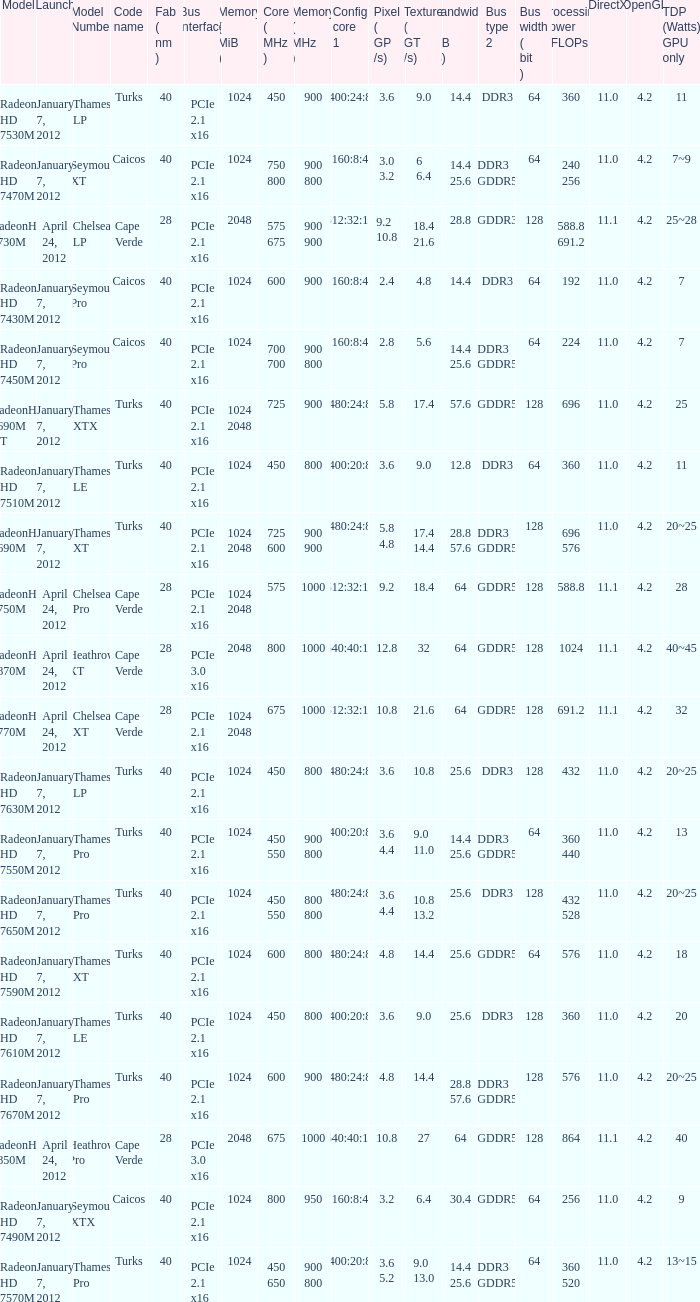What was the maximum fab (nm)? 40.0. 